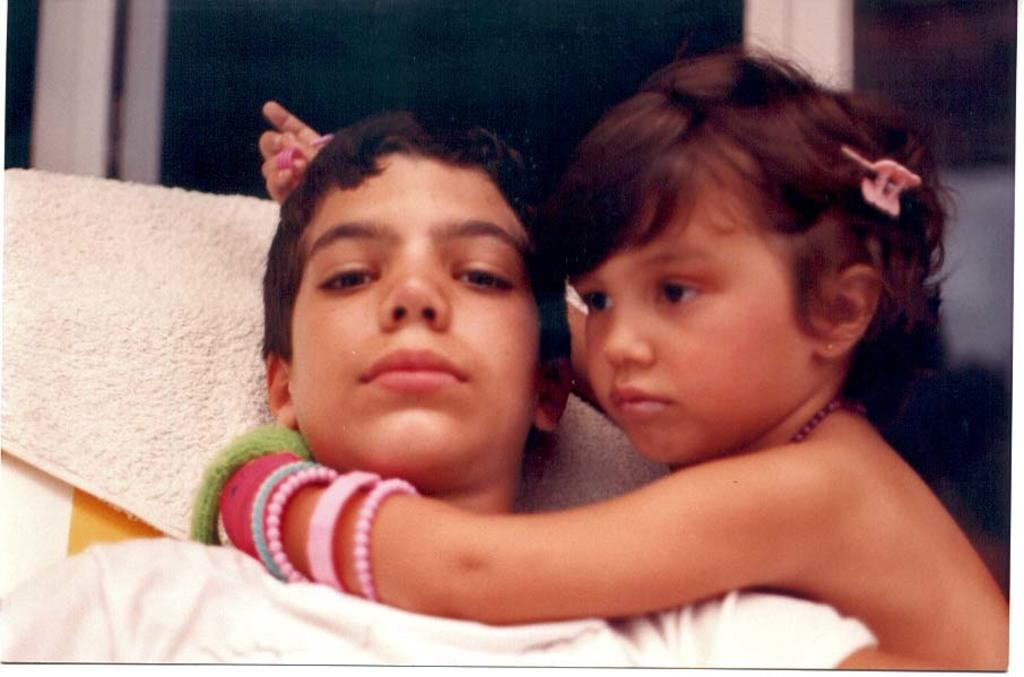Who is the main subject in the image? There is a girl in the image. What is the girl doing in the image? The girl is holding a boy in the image. Can you describe any objects in the image? There is a towel on the left side of the image. What type of juice is the girl drinking in the image? There is no juice present in the image; the girl is holding a boy. 